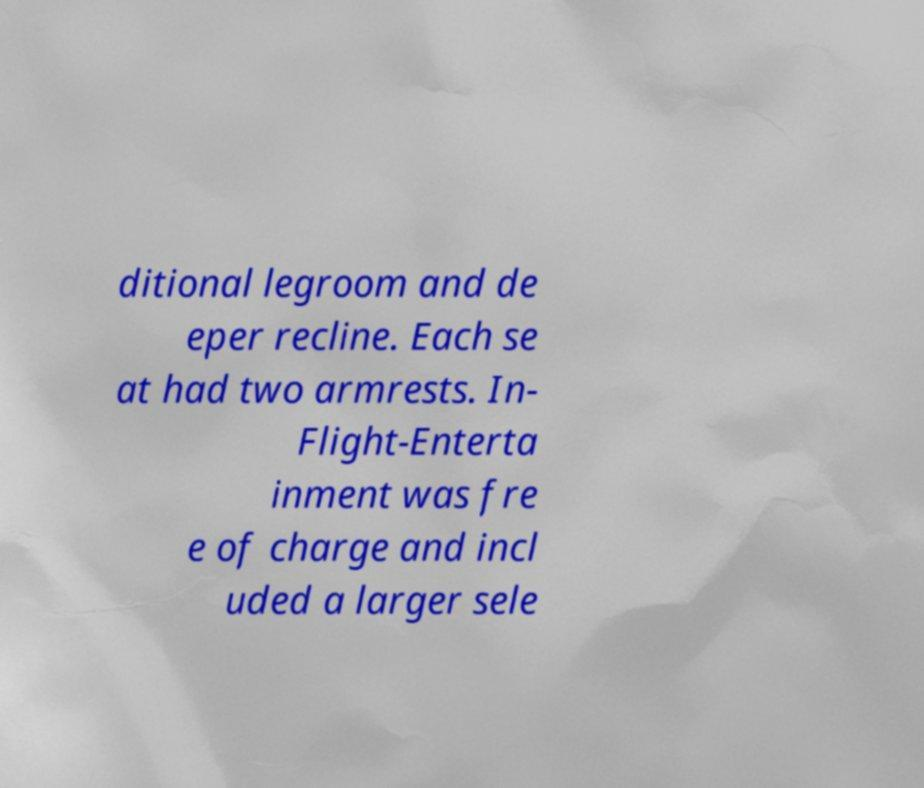Can you read and provide the text displayed in the image?This photo seems to have some interesting text. Can you extract and type it out for me? ditional legroom and de eper recline. Each se at had two armrests. In- Flight-Enterta inment was fre e of charge and incl uded a larger sele 